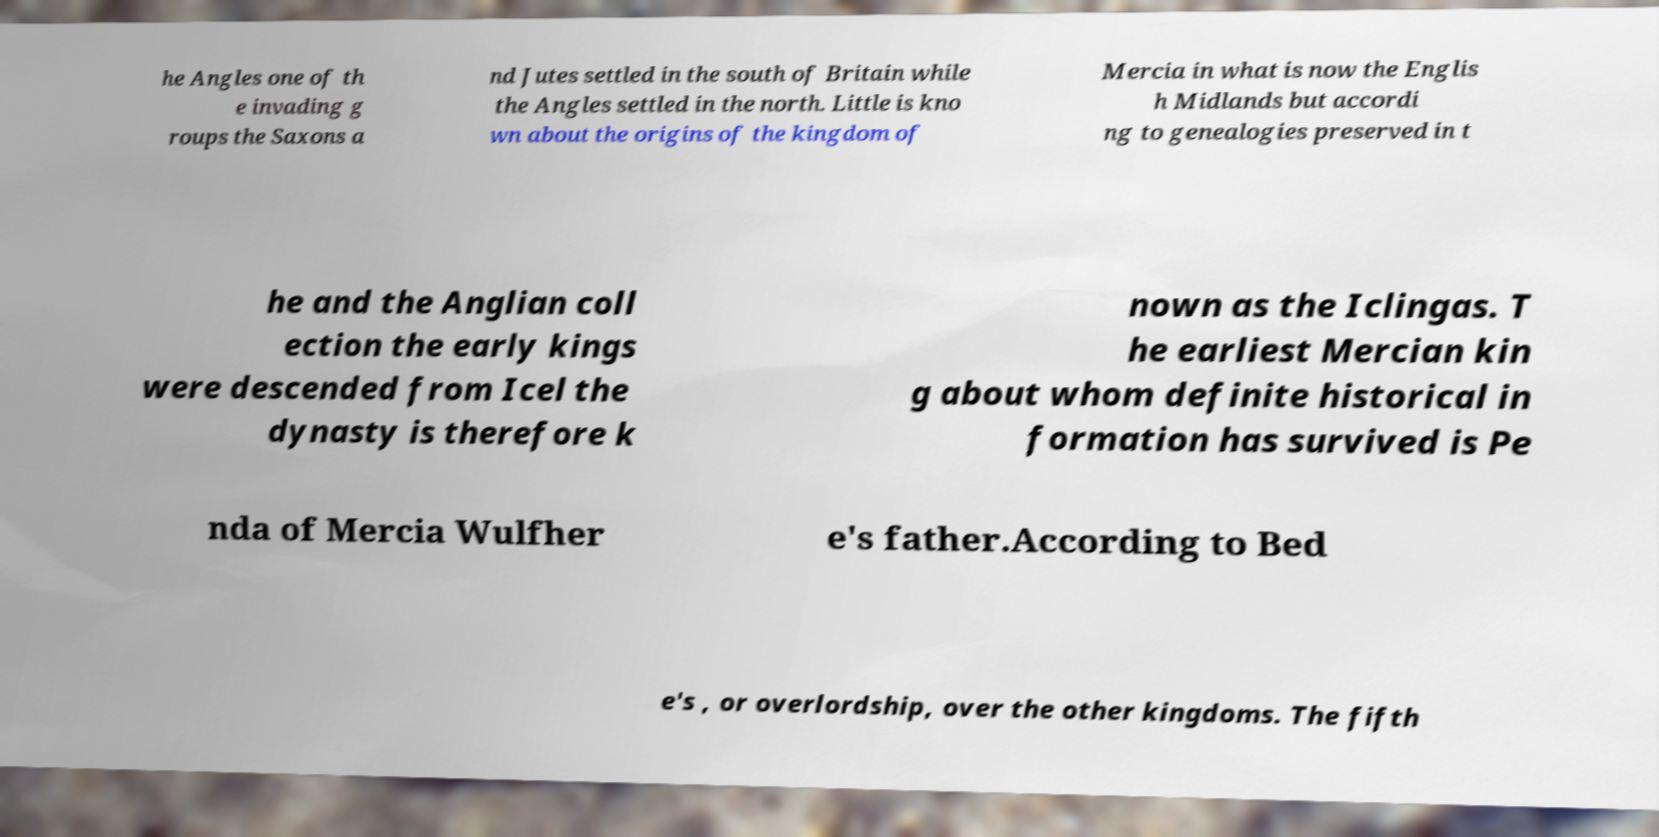Please identify and transcribe the text found in this image. he Angles one of th e invading g roups the Saxons a nd Jutes settled in the south of Britain while the Angles settled in the north. Little is kno wn about the origins of the kingdom of Mercia in what is now the Englis h Midlands but accordi ng to genealogies preserved in t he and the Anglian coll ection the early kings were descended from Icel the dynasty is therefore k nown as the Iclingas. T he earliest Mercian kin g about whom definite historical in formation has survived is Pe nda of Mercia Wulfher e's father.According to Bed e's , or overlordship, over the other kingdoms. The fifth 